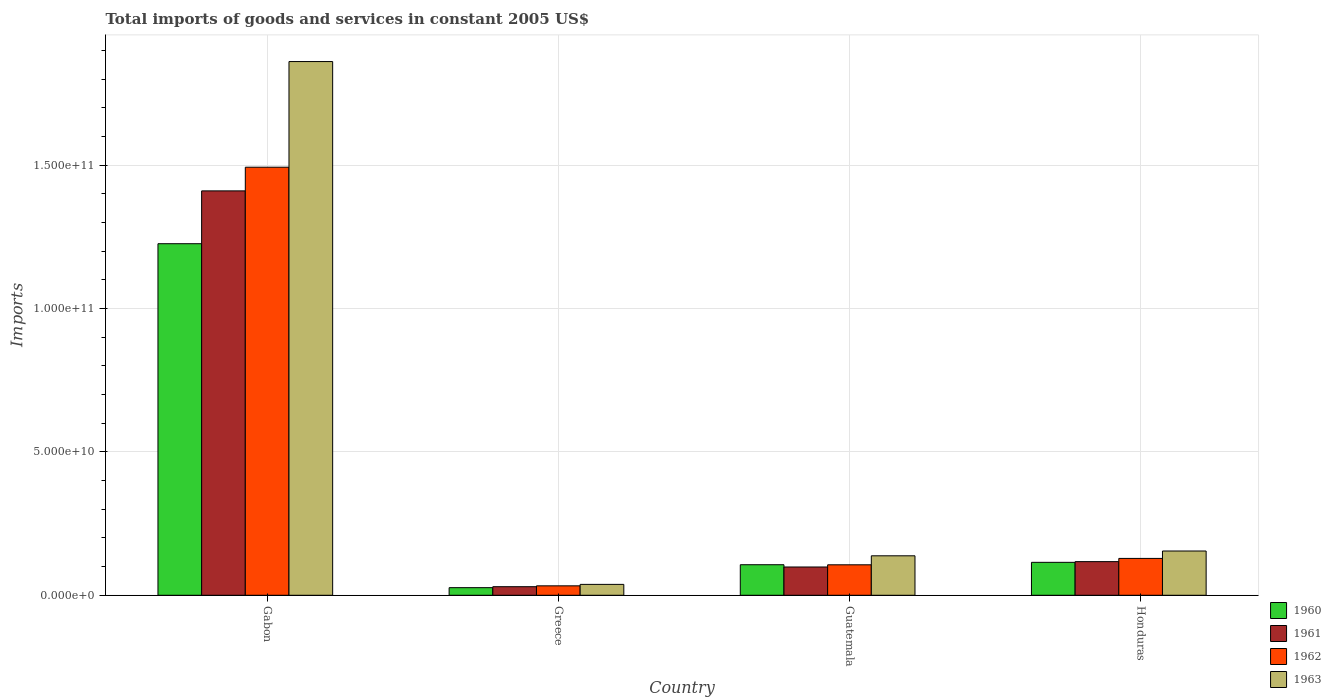Are the number of bars on each tick of the X-axis equal?
Provide a succinct answer. Yes. How many bars are there on the 3rd tick from the left?
Keep it short and to the point. 4. In how many cases, is the number of bars for a given country not equal to the number of legend labels?
Make the answer very short. 0. What is the total imports of goods and services in 1962 in Guatemala?
Offer a very short reply. 1.06e+1. Across all countries, what is the maximum total imports of goods and services in 1960?
Your answer should be compact. 1.23e+11. Across all countries, what is the minimum total imports of goods and services in 1962?
Provide a short and direct response. 3.29e+09. In which country was the total imports of goods and services in 1962 maximum?
Provide a succinct answer. Gabon. In which country was the total imports of goods and services in 1960 minimum?
Offer a terse response. Greece. What is the total total imports of goods and services in 1962 in the graph?
Ensure brevity in your answer.  1.76e+11. What is the difference between the total imports of goods and services in 1963 in Greece and that in Honduras?
Make the answer very short. -1.16e+1. What is the difference between the total imports of goods and services in 1963 in Guatemala and the total imports of goods and services in 1961 in Greece?
Give a very brief answer. 1.08e+1. What is the average total imports of goods and services in 1963 per country?
Make the answer very short. 5.48e+1. What is the difference between the total imports of goods and services of/in 1962 and total imports of goods and services of/in 1960 in Gabon?
Keep it short and to the point. 2.67e+1. In how many countries, is the total imports of goods and services in 1961 greater than 110000000000 US$?
Offer a terse response. 1. What is the ratio of the total imports of goods and services in 1962 in Gabon to that in Greece?
Give a very brief answer. 45.35. Is the total imports of goods and services in 1961 in Gabon less than that in Greece?
Make the answer very short. No. Is the difference between the total imports of goods and services in 1962 in Gabon and Honduras greater than the difference between the total imports of goods and services in 1960 in Gabon and Honduras?
Your answer should be very brief. Yes. What is the difference between the highest and the second highest total imports of goods and services in 1960?
Offer a very short reply. -1.11e+11. What is the difference between the highest and the lowest total imports of goods and services in 1962?
Make the answer very short. 1.46e+11. In how many countries, is the total imports of goods and services in 1963 greater than the average total imports of goods and services in 1963 taken over all countries?
Ensure brevity in your answer.  1. Is the sum of the total imports of goods and services in 1961 in Gabon and Guatemala greater than the maximum total imports of goods and services in 1963 across all countries?
Make the answer very short. No. Is it the case that in every country, the sum of the total imports of goods and services in 1962 and total imports of goods and services in 1963 is greater than the sum of total imports of goods and services in 1961 and total imports of goods and services in 1960?
Make the answer very short. No. Are all the bars in the graph horizontal?
Provide a succinct answer. No. How many countries are there in the graph?
Give a very brief answer. 4. Does the graph contain any zero values?
Give a very brief answer. No. Where does the legend appear in the graph?
Give a very brief answer. Bottom right. How are the legend labels stacked?
Offer a very short reply. Vertical. What is the title of the graph?
Make the answer very short. Total imports of goods and services in constant 2005 US$. Does "1985" appear as one of the legend labels in the graph?
Your response must be concise. No. What is the label or title of the Y-axis?
Make the answer very short. Imports. What is the Imports of 1960 in Gabon?
Your answer should be very brief. 1.23e+11. What is the Imports of 1961 in Gabon?
Your response must be concise. 1.41e+11. What is the Imports in 1962 in Gabon?
Keep it short and to the point. 1.49e+11. What is the Imports of 1963 in Gabon?
Give a very brief answer. 1.86e+11. What is the Imports in 1960 in Greece?
Offer a terse response. 2.65e+09. What is the Imports of 1961 in Greece?
Your response must be concise. 2.99e+09. What is the Imports of 1962 in Greece?
Offer a terse response. 3.29e+09. What is the Imports of 1963 in Greece?
Your answer should be very brief. 3.80e+09. What is the Imports of 1960 in Guatemala?
Keep it short and to the point. 1.07e+1. What is the Imports in 1961 in Guatemala?
Ensure brevity in your answer.  9.86e+09. What is the Imports of 1962 in Guatemala?
Your answer should be very brief. 1.06e+1. What is the Imports of 1963 in Guatemala?
Keep it short and to the point. 1.38e+1. What is the Imports of 1960 in Honduras?
Give a very brief answer. 1.15e+1. What is the Imports in 1961 in Honduras?
Ensure brevity in your answer.  1.17e+1. What is the Imports of 1962 in Honduras?
Make the answer very short. 1.29e+1. What is the Imports in 1963 in Honduras?
Give a very brief answer. 1.54e+1. Across all countries, what is the maximum Imports in 1960?
Your response must be concise. 1.23e+11. Across all countries, what is the maximum Imports in 1961?
Provide a succinct answer. 1.41e+11. Across all countries, what is the maximum Imports of 1962?
Provide a short and direct response. 1.49e+11. Across all countries, what is the maximum Imports in 1963?
Keep it short and to the point. 1.86e+11. Across all countries, what is the minimum Imports of 1960?
Your answer should be very brief. 2.65e+09. Across all countries, what is the minimum Imports in 1961?
Your response must be concise. 2.99e+09. Across all countries, what is the minimum Imports of 1962?
Ensure brevity in your answer.  3.29e+09. Across all countries, what is the minimum Imports of 1963?
Your response must be concise. 3.80e+09. What is the total Imports of 1960 in the graph?
Provide a succinct answer. 1.47e+11. What is the total Imports in 1961 in the graph?
Your response must be concise. 1.66e+11. What is the total Imports of 1962 in the graph?
Your response must be concise. 1.76e+11. What is the total Imports in 1963 in the graph?
Provide a succinct answer. 2.19e+11. What is the difference between the Imports in 1960 in Gabon and that in Greece?
Your answer should be very brief. 1.20e+11. What is the difference between the Imports in 1961 in Gabon and that in Greece?
Make the answer very short. 1.38e+11. What is the difference between the Imports of 1962 in Gabon and that in Greece?
Your response must be concise. 1.46e+11. What is the difference between the Imports of 1963 in Gabon and that in Greece?
Make the answer very short. 1.82e+11. What is the difference between the Imports in 1960 in Gabon and that in Guatemala?
Your answer should be compact. 1.12e+11. What is the difference between the Imports of 1961 in Gabon and that in Guatemala?
Make the answer very short. 1.31e+11. What is the difference between the Imports in 1962 in Gabon and that in Guatemala?
Keep it short and to the point. 1.39e+11. What is the difference between the Imports in 1963 in Gabon and that in Guatemala?
Keep it short and to the point. 1.72e+11. What is the difference between the Imports in 1960 in Gabon and that in Honduras?
Offer a terse response. 1.11e+11. What is the difference between the Imports in 1961 in Gabon and that in Honduras?
Provide a short and direct response. 1.29e+11. What is the difference between the Imports of 1962 in Gabon and that in Honduras?
Ensure brevity in your answer.  1.36e+11. What is the difference between the Imports in 1963 in Gabon and that in Honduras?
Your response must be concise. 1.71e+11. What is the difference between the Imports of 1960 in Greece and that in Guatemala?
Make the answer very short. -8.00e+09. What is the difference between the Imports in 1961 in Greece and that in Guatemala?
Your answer should be compact. -6.87e+09. What is the difference between the Imports in 1962 in Greece and that in Guatemala?
Provide a succinct answer. -7.34e+09. What is the difference between the Imports in 1963 in Greece and that in Guatemala?
Keep it short and to the point. -9.96e+09. What is the difference between the Imports in 1960 in Greece and that in Honduras?
Keep it short and to the point. -8.83e+09. What is the difference between the Imports in 1961 in Greece and that in Honduras?
Offer a terse response. -8.74e+09. What is the difference between the Imports in 1962 in Greece and that in Honduras?
Your answer should be very brief. -9.56e+09. What is the difference between the Imports in 1963 in Greece and that in Honduras?
Give a very brief answer. -1.16e+1. What is the difference between the Imports in 1960 in Guatemala and that in Honduras?
Provide a succinct answer. -8.33e+08. What is the difference between the Imports of 1961 in Guatemala and that in Honduras?
Your answer should be compact. -1.87e+09. What is the difference between the Imports in 1962 in Guatemala and that in Honduras?
Offer a very short reply. -2.23e+09. What is the difference between the Imports in 1963 in Guatemala and that in Honduras?
Provide a succinct answer. -1.68e+09. What is the difference between the Imports of 1960 in Gabon and the Imports of 1961 in Greece?
Give a very brief answer. 1.20e+11. What is the difference between the Imports in 1960 in Gabon and the Imports in 1962 in Greece?
Make the answer very short. 1.19e+11. What is the difference between the Imports in 1960 in Gabon and the Imports in 1963 in Greece?
Keep it short and to the point. 1.19e+11. What is the difference between the Imports in 1961 in Gabon and the Imports in 1962 in Greece?
Your answer should be very brief. 1.38e+11. What is the difference between the Imports of 1961 in Gabon and the Imports of 1963 in Greece?
Your answer should be very brief. 1.37e+11. What is the difference between the Imports of 1962 in Gabon and the Imports of 1963 in Greece?
Keep it short and to the point. 1.45e+11. What is the difference between the Imports in 1960 in Gabon and the Imports in 1961 in Guatemala?
Provide a succinct answer. 1.13e+11. What is the difference between the Imports in 1960 in Gabon and the Imports in 1962 in Guatemala?
Your response must be concise. 1.12e+11. What is the difference between the Imports in 1960 in Gabon and the Imports in 1963 in Guatemala?
Provide a succinct answer. 1.09e+11. What is the difference between the Imports in 1961 in Gabon and the Imports in 1962 in Guatemala?
Provide a succinct answer. 1.30e+11. What is the difference between the Imports of 1961 in Gabon and the Imports of 1963 in Guatemala?
Ensure brevity in your answer.  1.27e+11. What is the difference between the Imports of 1962 in Gabon and the Imports of 1963 in Guatemala?
Ensure brevity in your answer.  1.35e+11. What is the difference between the Imports in 1960 in Gabon and the Imports in 1961 in Honduras?
Ensure brevity in your answer.  1.11e+11. What is the difference between the Imports in 1960 in Gabon and the Imports in 1962 in Honduras?
Provide a short and direct response. 1.10e+11. What is the difference between the Imports in 1960 in Gabon and the Imports in 1963 in Honduras?
Your response must be concise. 1.07e+11. What is the difference between the Imports in 1961 in Gabon and the Imports in 1962 in Honduras?
Your answer should be very brief. 1.28e+11. What is the difference between the Imports in 1961 in Gabon and the Imports in 1963 in Honduras?
Your answer should be very brief. 1.26e+11. What is the difference between the Imports in 1962 in Gabon and the Imports in 1963 in Honduras?
Provide a short and direct response. 1.34e+11. What is the difference between the Imports in 1960 in Greece and the Imports in 1961 in Guatemala?
Offer a very short reply. -7.21e+09. What is the difference between the Imports in 1960 in Greece and the Imports in 1962 in Guatemala?
Make the answer very short. -7.97e+09. What is the difference between the Imports in 1960 in Greece and the Imports in 1963 in Guatemala?
Offer a very short reply. -1.11e+1. What is the difference between the Imports of 1961 in Greece and the Imports of 1962 in Guatemala?
Give a very brief answer. -7.64e+09. What is the difference between the Imports in 1961 in Greece and the Imports in 1963 in Guatemala?
Offer a very short reply. -1.08e+1. What is the difference between the Imports of 1962 in Greece and the Imports of 1963 in Guatemala?
Provide a succinct answer. -1.05e+1. What is the difference between the Imports of 1960 in Greece and the Imports of 1961 in Honduras?
Provide a short and direct response. -9.08e+09. What is the difference between the Imports of 1960 in Greece and the Imports of 1962 in Honduras?
Your response must be concise. -1.02e+1. What is the difference between the Imports of 1960 in Greece and the Imports of 1963 in Honduras?
Keep it short and to the point. -1.28e+1. What is the difference between the Imports of 1961 in Greece and the Imports of 1962 in Honduras?
Make the answer very short. -9.86e+09. What is the difference between the Imports of 1961 in Greece and the Imports of 1963 in Honduras?
Your answer should be compact. -1.24e+1. What is the difference between the Imports of 1962 in Greece and the Imports of 1963 in Honduras?
Offer a very short reply. -1.21e+1. What is the difference between the Imports in 1960 in Guatemala and the Imports in 1961 in Honduras?
Ensure brevity in your answer.  -1.08e+09. What is the difference between the Imports of 1960 in Guatemala and the Imports of 1962 in Honduras?
Provide a short and direct response. -2.20e+09. What is the difference between the Imports of 1960 in Guatemala and the Imports of 1963 in Honduras?
Your answer should be compact. -4.78e+09. What is the difference between the Imports of 1961 in Guatemala and the Imports of 1962 in Honduras?
Your response must be concise. -2.99e+09. What is the difference between the Imports of 1961 in Guatemala and the Imports of 1963 in Honduras?
Ensure brevity in your answer.  -5.58e+09. What is the difference between the Imports of 1962 in Guatemala and the Imports of 1963 in Honduras?
Your response must be concise. -4.81e+09. What is the average Imports in 1960 per country?
Your answer should be very brief. 3.68e+1. What is the average Imports in 1961 per country?
Provide a succinct answer. 4.14e+1. What is the average Imports of 1962 per country?
Provide a succinct answer. 4.40e+1. What is the average Imports in 1963 per country?
Provide a short and direct response. 5.48e+1. What is the difference between the Imports in 1960 and Imports in 1961 in Gabon?
Ensure brevity in your answer.  -1.84e+1. What is the difference between the Imports of 1960 and Imports of 1962 in Gabon?
Your response must be concise. -2.67e+1. What is the difference between the Imports in 1960 and Imports in 1963 in Gabon?
Offer a very short reply. -6.35e+1. What is the difference between the Imports in 1961 and Imports in 1962 in Gabon?
Your answer should be compact. -8.26e+09. What is the difference between the Imports in 1961 and Imports in 1963 in Gabon?
Offer a very short reply. -4.51e+1. What is the difference between the Imports in 1962 and Imports in 1963 in Gabon?
Offer a very short reply. -3.68e+1. What is the difference between the Imports of 1960 and Imports of 1961 in Greece?
Offer a terse response. -3.37e+08. What is the difference between the Imports in 1960 and Imports in 1962 in Greece?
Ensure brevity in your answer.  -6.39e+08. What is the difference between the Imports of 1960 and Imports of 1963 in Greece?
Offer a terse response. -1.15e+09. What is the difference between the Imports of 1961 and Imports of 1962 in Greece?
Make the answer very short. -3.02e+08. What is the difference between the Imports in 1961 and Imports in 1963 in Greece?
Give a very brief answer. -8.09e+08. What is the difference between the Imports of 1962 and Imports of 1963 in Greece?
Offer a terse response. -5.06e+08. What is the difference between the Imports of 1960 and Imports of 1961 in Guatemala?
Ensure brevity in your answer.  7.93e+08. What is the difference between the Imports in 1960 and Imports in 1962 in Guatemala?
Make the answer very short. 2.58e+07. What is the difference between the Imports of 1960 and Imports of 1963 in Guatemala?
Offer a terse response. -3.11e+09. What is the difference between the Imports in 1961 and Imports in 1962 in Guatemala?
Provide a succinct answer. -7.67e+08. What is the difference between the Imports in 1961 and Imports in 1963 in Guatemala?
Offer a very short reply. -3.90e+09. What is the difference between the Imports of 1962 and Imports of 1963 in Guatemala?
Offer a very short reply. -3.13e+09. What is the difference between the Imports in 1960 and Imports in 1961 in Honduras?
Offer a very short reply. -2.44e+08. What is the difference between the Imports in 1960 and Imports in 1962 in Honduras?
Make the answer very short. -1.37e+09. What is the difference between the Imports of 1960 and Imports of 1963 in Honduras?
Provide a short and direct response. -3.95e+09. What is the difference between the Imports of 1961 and Imports of 1962 in Honduras?
Ensure brevity in your answer.  -1.12e+09. What is the difference between the Imports of 1961 and Imports of 1963 in Honduras?
Provide a succinct answer. -3.71e+09. What is the difference between the Imports in 1962 and Imports in 1963 in Honduras?
Ensure brevity in your answer.  -2.58e+09. What is the ratio of the Imports of 1960 in Gabon to that in Greece?
Your answer should be very brief. 46.22. What is the ratio of the Imports in 1961 in Gabon to that in Greece?
Make the answer very short. 47.18. What is the ratio of the Imports in 1962 in Gabon to that in Greece?
Your response must be concise. 45.35. What is the ratio of the Imports in 1963 in Gabon to that in Greece?
Make the answer very short. 49. What is the ratio of the Imports of 1960 in Gabon to that in Guatemala?
Make the answer very short. 11.51. What is the ratio of the Imports in 1961 in Gabon to that in Guatemala?
Your response must be concise. 14.3. What is the ratio of the Imports of 1962 in Gabon to that in Guatemala?
Your answer should be very brief. 14.05. What is the ratio of the Imports of 1963 in Gabon to that in Guatemala?
Ensure brevity in your answer.  13.52. What is the ratio of the Imports in 1960 in Gabon to that in Honduras?
Make the answer very short. 10.67. What is the ratio of the Imports in 1961 in Gabon to that in Honduras?
Ensure brevity in your answer.  12.02. What is the ratio of the Imports in 1962 in Gabon to that in Honduras?
Your answer should be compact. 11.61. What is the ratio of the Imports of 1963 in Gabon to that in Honduras?
Your answer should be compact. 12.06. What is the ratio of the Imports in 1960 in Greece to that in Guatemala?
Give a very brief answer. 0.25. What is the ratio of the Imports in 1961 in Greece to that in Guatemala?
Give a very brief answer. 0.3. What is the ratio of the Imports in 1962 in Greece to that in Guatemala?
Give a very brief answer. 0.31. What is the ratio of the Imports of 1963 in Greece to that in Guatemala?
Give a very brief answer. 0.28. What is the ratio of the Imports of 1960 in Greece to that in Honduras?
Give a very brief answer. 0.23. What is the ratio of the Imports of 1961 in Greece to that in Honduras?
Provide a succinct answer. 0.25. What is the ratio of the Imports in 1962 in Greece to that in Honduras?
Provide a succinct answer. 0.26. What is the ratio of the Imports in 1963 in Greece to that in Honduras?
Make the answer very short. 0.25. What is the ratio of the Imports in 1960 in Guatemala to that in Honduras?
Keep it short and to the point. 0.93. What is the ratio of the Imports of 1961 in Guatemala to that in Honduras?
Provide a short and direct response. 0.84. What is the ratio of the Imports in 1962 in Guatemala to that in Honduras?
Provide a short and direct response. 0.83. What is the ratio of the Imports of 1963 in Guatemala to that in Honduras?
Your response must be concise. 0.89. What is the difference between the highest and the second highest Imports in 1960?
Give a very brief answer. 1.11e+11. What is the difference between the highest and the second highest Imports of 1961?
Provide a short and direct response. 1.29e+11. What is the difference between the highest and the second highest Imports in 1962?
Keep it short and to the point. 1.36e+11. What is the difference between the highest and the second highest Imports of 1963?
Provide a short and direct response. 1.71e+11. What is the difference between the highest and the lowest Imports in 1960?
Your answer should be compact. 1.20e+11. What is the difference between the highest and the lowest Imports in 1961?
Offer a very short reply. 1.38e+11. What is the difference between the highest and the lowest Imports of 1962?
Make the answer very short. 1.46e+11. What is the difference between the highest and the lowest Imports of 1963?
Ensure brevity in your answer.  1.82e+11. 